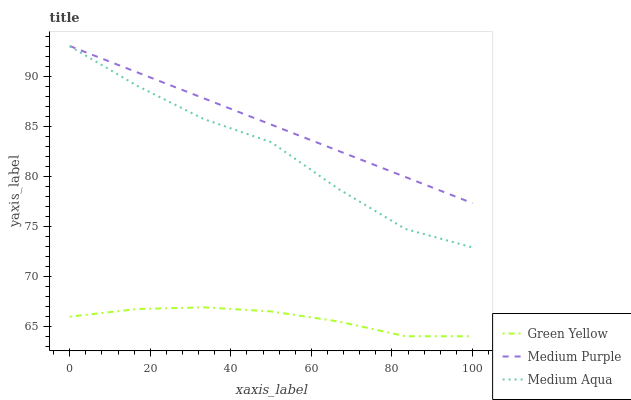Does Green Yellow have the minimum area under the curve?
Answer yes or no. Yes. Does Medium Purple have the maximum area under the curve?
Answer yes or no. Yes. Does Medium Aqua have the minimum area under the curve?
Answer yes or no. No. Does Medium Aqua have the maximum area under the curve?
Answer yes or no. No. Is Medium Purple the smoothest?
Answer yes or no. Yes. Is Medium Aqua the roughest?
Answer yes or no. Yes. Is Green Yellow the smoothest?
Answer yes or no. No. Is Green Yellow the roughest?
Answer yes or no. No. Does Medium Aqua have the lowest value?
Answer yes or no. No. Does Medium Aqua have the highest value?
Answer yes or no. No. Is Medium Aqua less than Medium Purple?
Answer yes or no. Yes. Is Medium Aqua greater than Green Yellow?
Answer yes or no. Yes. Does Medium Aqua intersect Medium Purple?
Answer yes or no. No. 